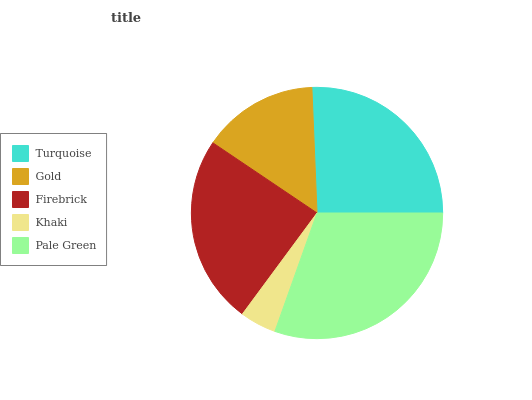Is Khaki the minimum?
Answer yes or no. Yes. Is Pale Green the maximum?
Answer yes or no. Yes. Is Gold the minimum?
Answer yes or no. No. Is Gold the maximum?
Answer yes or no. No. Is Turquoise greater than Gold?
Answer yes or no. Yes. Is Gold less than Turquoise?
Answer yes or no. Yes. Is Gold greater than Turquoise?
Answer yes or no. No. Is Turquoise less than Gold?
Answer yes or no. No. Is Firebrick the high median?
Answer yes or no. Yes. Is Firebrick the low median?
Answer yes or no. Yes. Is Gold the high median?
Answer yes or no. No. Is Gold the low median?
Answer yes or no. No. 